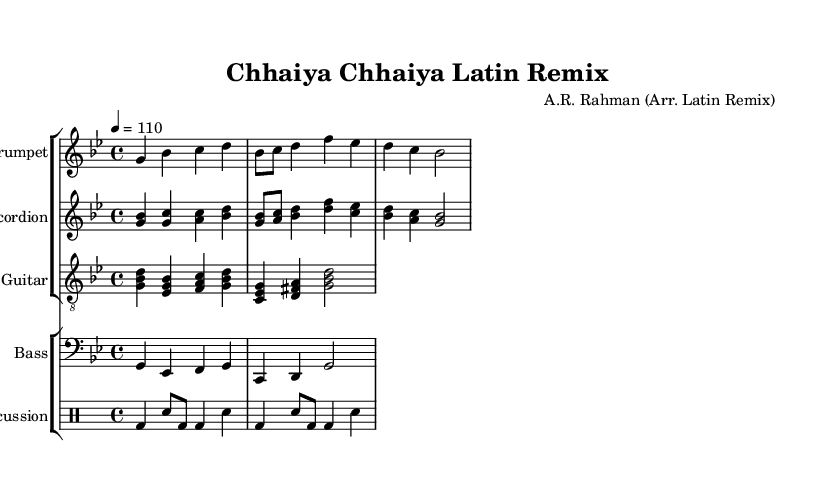what is the key signature of this music? The key signature is G minor, indicated by the presence of two flats (B flat and E flat) in the staff.
Answer: G minor what is the time signature of this piece? The time signature shown in the music is 4/4, which means there are four beats in each measure.
Answer: 4/4 what is the tempo marking for this arrangement? The tempo marking of the piece indicates a speed of quarter note equals 110 beats per minute.
Answer: 110 how many measures are in the trumpet part? By counting the measures in the trumpet staff provided, there are a total of 4 measures.
Answer: 4 which instruments are included in this arrangement? The arrangement includes trumpet, accordion, guitar, bass, and percussion. This is determined by identifying the instrument names listed above each staff.
Answer: trumpet, accordion, guitar, bass, percussion which instrument plays the melody line? The melody line is played by the trumpet, which is indicated by the melody section present under the trumpet staff.
Answer: trumpet how does the rhythm in the percussion section compare to the melody? The percussion section maintains a driving rhythm with a combination of bass drum and snare hits, contributing to a lively and danceable beat that supports the melody's syncopation. The measures of percussion show consistent beat patterns, while the melody exhibits variation.
Answer: driving rhythm 